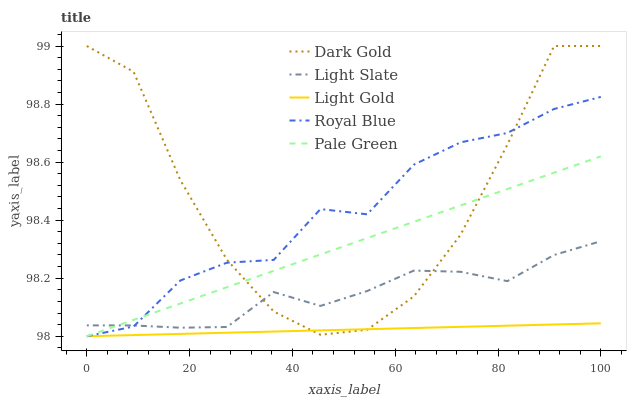Does Light Gold have the minimum area under the curve?
Answer yes or no. Yes. Does Dark Gold have the maximum area under the curve?
Answer yes or no. Yes. Does Royal Blue have the minimum area under the curve?
Answer yes or no. No. Does Royal Blue have the maximum area under the curve?
Answer yes or no. No. Is Pale Green the smoothest?
Answer yes or no. Yes. Is Dark Gold the roughest?
Answer yes or no. Yes. Is Royal Blue the smoothest?
Answer yes or no. No. Is Royal Blue the roughest?
Answer yes or no. No. Does Royal Blue have the lowest value?
Answer yes or no. Yes. Does Dark Gold have the lowest value?
Answer yes or no. No. Does Dark Gold have the highest value?
Answer yes or no. Yes. Does Royal Blue have the highest value?
Answer yes or no. No. Is Light Gold less than Light Slate?
Answer yes or no. Yes. Is Light Slate greater than Light Gold?
Answer yes or no. Yes. Does Dark Gold intersect Pale Green?
Answer yes or no. Yes. Is Dark Gold less than Pale Green?
Answer yes or no. No. Is Dark Gold greater than Pale Green?
Answer yes or no. No. Does Light Gold intersect Light Slate?
Answer yes or no. No. 